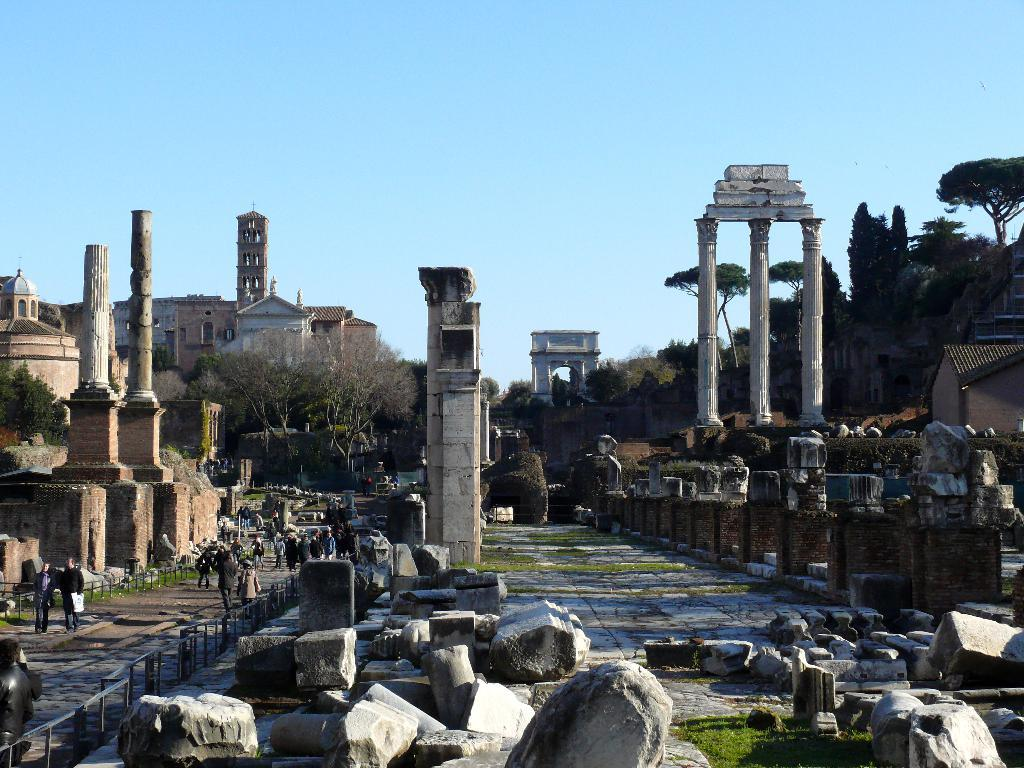What can be seen in the foreground of the image? In the foreground of the image, there are stones and a pavement. What type of structures are present in the image? There are monuments and buildings in the image. What type of vegetation can be seen in the image? Trees are present in the image. What are the people in the image doing? People are walking on the pavement in the image. What is visible in the background of the image? The sky is visible in the image. What type of breakfast is being served on the throne in the image? There is no throne or breakfast present in the image. How many steps are visible in the image? There is no mention of steps in the image, only a pavement and stones in the foreground. 